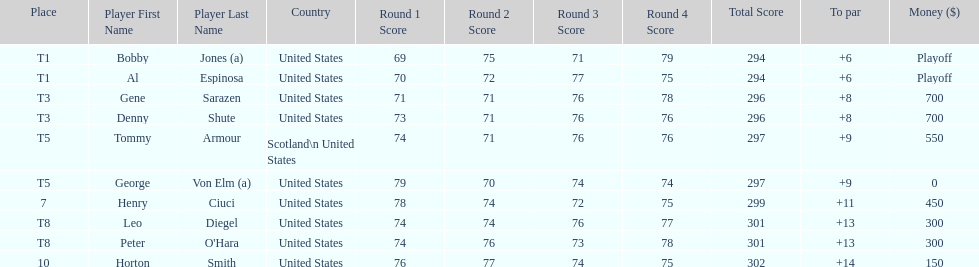Who finished next after bobby jones and al espinosa? Gene Sarazen, Denny Shute. 